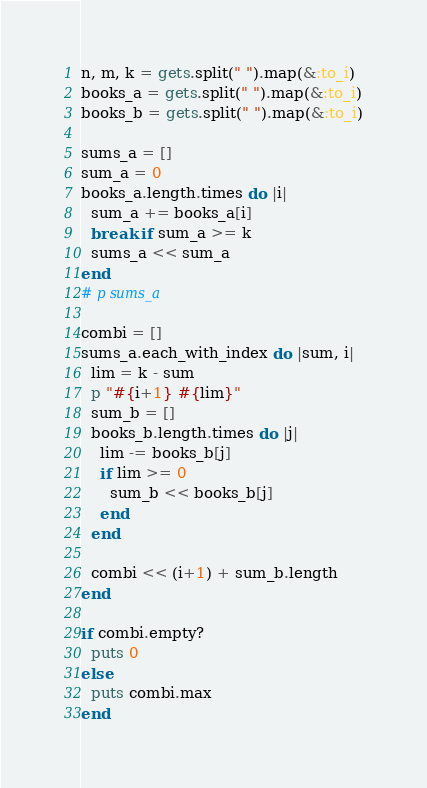<code> <loc_0><loc_0><loc_500><loc_500><_Ruby_>n, m, k = gets.split(" ").map(&:to_i)
books_a = gets.split(" ").map(&:to_i)
books_b = gets.split(" ").map(&:to_i)

sums_a = []
sum_a = 0
books_a.length.times do |i|
  sum_a += books_a[i]
  break if sum_a >= k
  sums_a << sum_a
end
# p sums_a

combi = []
sums_a.each_with_index do |sum, i|
  lim = k - sum
  p "#{i+1} #{lim}"
  sum_b = []
  books_b.length.times do |j|
    lim -= books_b[j]
    if lim >= 0
      sum_b << books_b[j]
    end
  end
  
  combi << (i+1) + sum_b.length
end

if combi.empty?
  puts 0
else
  puts combi.max
end</code> 